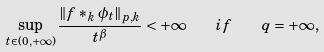<formula> <loc_0><loc_0><loc_500><loc_500>\sup _ { t \in ( 0 , + \infty ) } \frac { \| f \ast _ { k } \phi _ { t } \| _ { p , k } } { t ^ { \beta } } < + \infty \quad i f \quad q = + \infty ,</formula> 